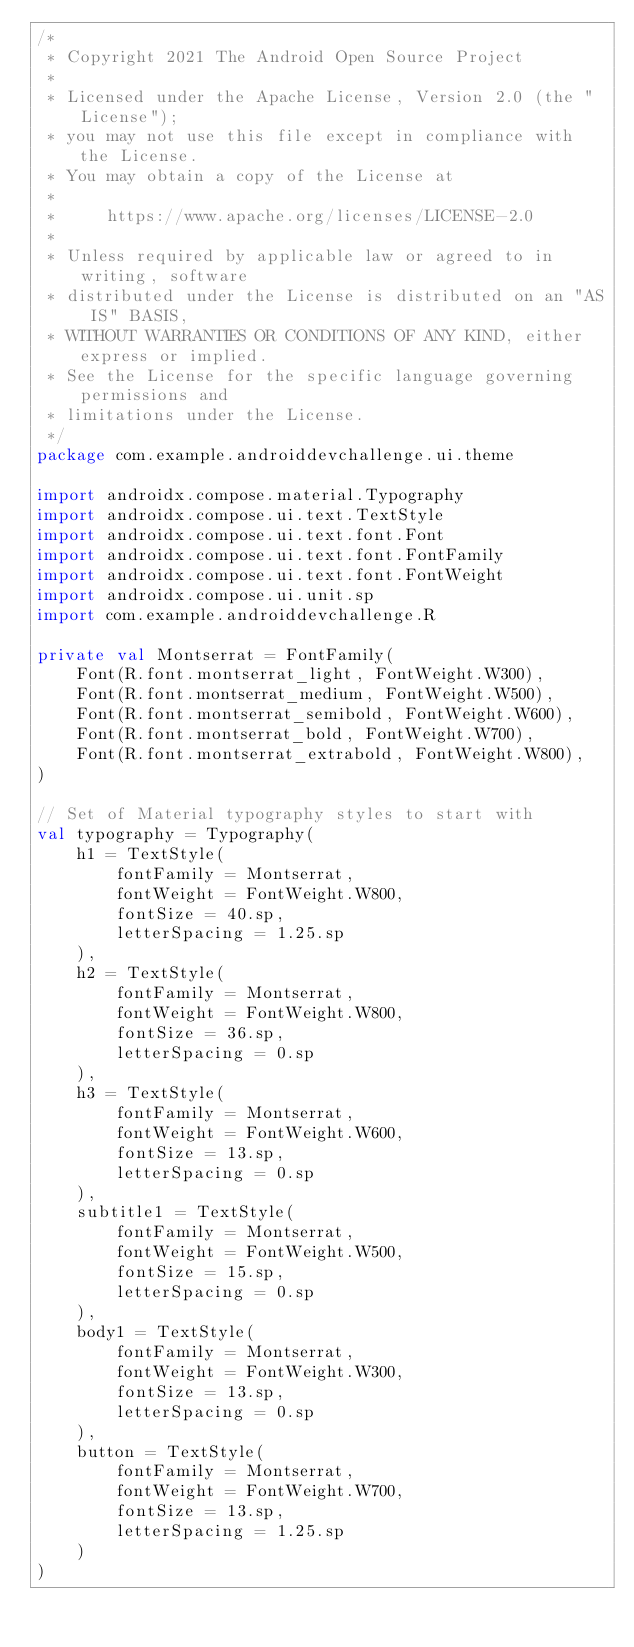Convert code to text. <code><loc_0><loc_0><loc_500><loc_500><_Kotlin_>/*
 * Copyright 2021 The Android Open Source Project
 *
 * Licensed under the Apache License, Version 2.0 (the "License");
 * you may not use this file except in compliance with the License.
 * You may obtain a copy of the License at
 *
 *     https://www.apache.org/licenses/LICENSE-2.0
 *
 * Unless required by applicable law or agreed to in writing, software
 * distributed under the License is distributed on an "AS IS" BASIS,
 * WITHOUT WARRANTIES OR CONDITIONS OF ANY KIND, either express or implied.
 * See the License for the specific language governing permissions and
 * limitations under the License.
 */
package com.example.androiddevchallenge.ui.theme

import androidx.compose.material.Typography
import androidx.compose.ui.text.TextStyle
import androidx.compose.ui.text.font.Font
import androidx.compose.ui.text.font.FontFamily
import androidx.compose.ui.text.font.FontWeight
import androidx.compose.ui.unit.sp
import com.example.androiddevchallenge.R

private val Montserrat = FontFamily(
    Font(R.font.montserrat_light, FontWeight.W300),
    Font(R.font.montserrat_medium, FontWeight.W500),
    Font(R.font.montserrat_semibold, FontWeight.W600),
    Font(R.font.montserrat_bold, FontWeight.W700),
    Font(R.font.montserrat_extrabold, FontWeight.W800),
)

// Set of Material typography styles to start with
val typography = Typography(
    h1 = TextStyle(
        fontFamily = Montserrat,
        fontWeight = FontWeight.W800,
        fontSize = 40.sp,
        letterSpacing = 1.25.sp
    ),
    h2 = TextStyle(
        fontFamily = Montserrat,
        fontWeight = FontWeight.W800,
        fontSize = 36.sp,
        letterSpacing = 0.sp
    ),
    h3 = TextStyle(
        fontFamily = Montserrat,
        fontWeight = FontWeight.W600,
        fontSize = 13.sp,
        letterSpacing = 0.sp
    ),
    subtitle1 = TextStyle(
        fontFamily = Montserrat,
        fontWeight = FontWeight.W500,
        fontSize = 15.sp,
        letterSpacing = 0.sp
    ),
    body1 = TextStyle(
        fontFamily = Montserrat,
        fontWeight = FontWeight.W300,
        fontSize = 13.sp,
        letterSpacing = 0.sp
    ),
    button = TextStyle(
        fontFamily = Montserrat,
        fontWeight = FontWeight.W700,
        fontSize = 13.sp,
        letterSpacing = 1.25.sp
    )
)
</code> 